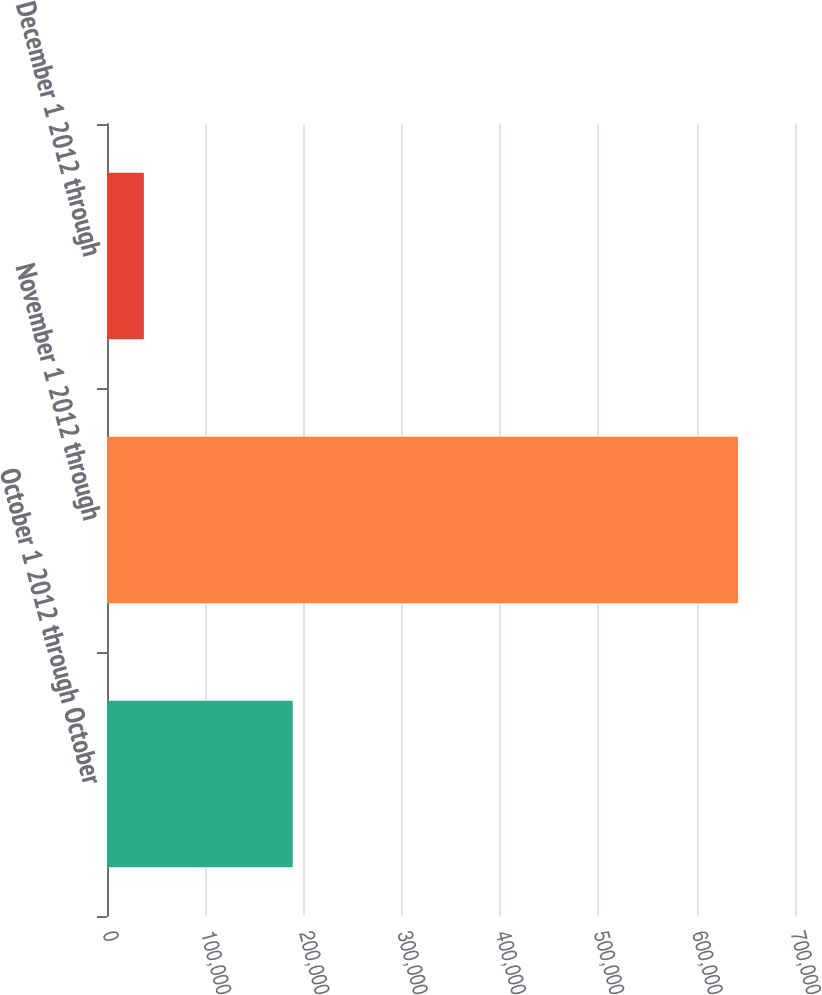Convert chart to OTSL. <chart><loc_0><loc_0><loc_500><loc_500><bar_chart><fcel>October 1 2012 through October<fcel>November 1 2012 through<fcel>December 1 2012 through<nl><fcel>189000<fcel>642000<fcel>37500<nl></chart> 